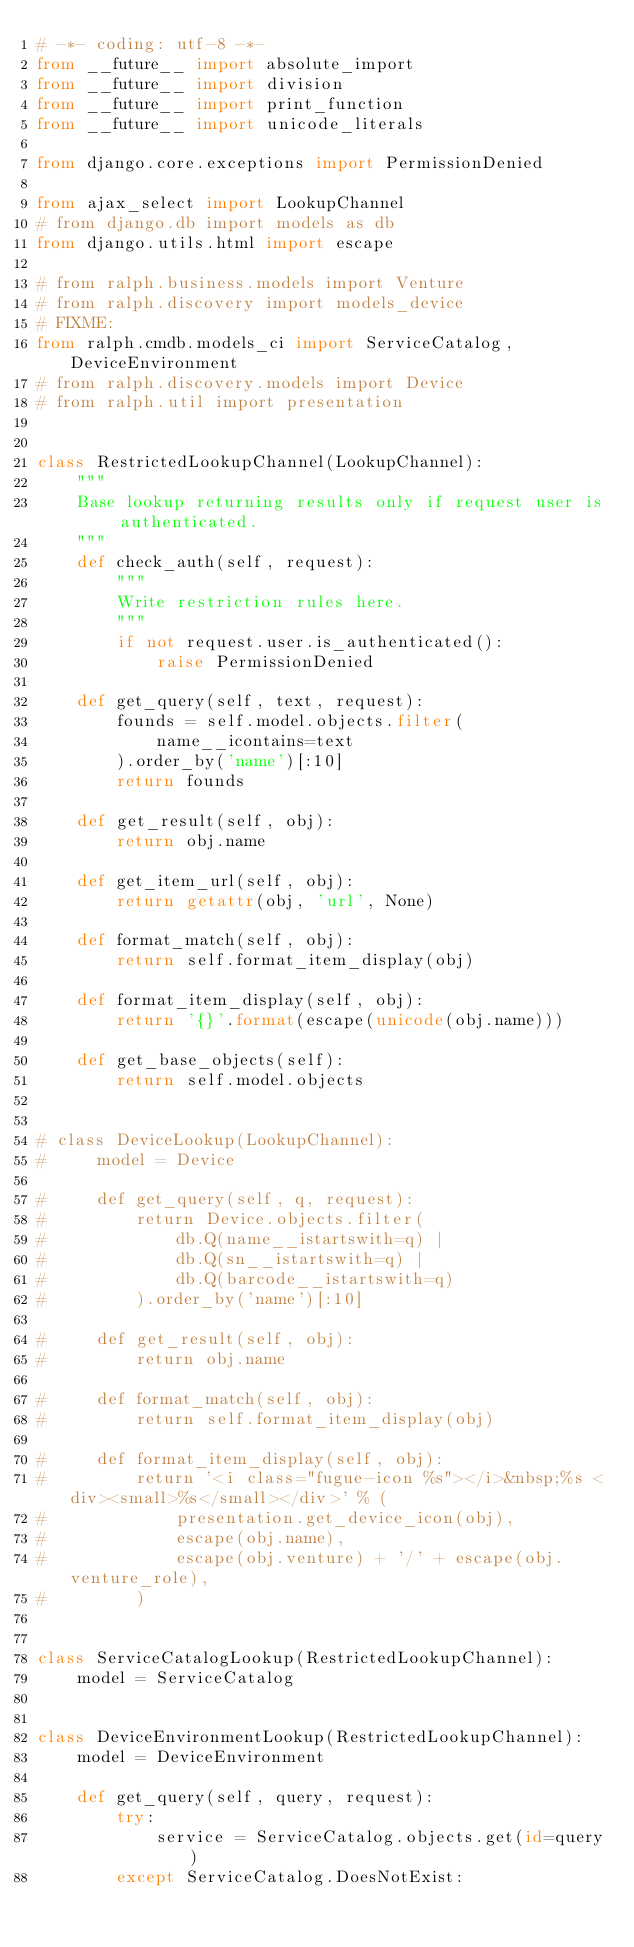Convert code to text. <code><loc_0><loc_0><loc_500><loc_500><_Python_># -*- coding: utf-8 -*-
from __future__ import absolute_import
from __future__ import division
from __future__ import print_function
from __future__ import unicode_literals

from django.core.exceptions import PermissionDenied

from ajax_select import LookupChannel
# from django.db import models as db
from django.utils.html import escape

# from ralph.business.models import Venture
# from ralph.discovery import models_device
# FIXME:
from ralph.cmdb.models_ci import ServiceCatalog, DeviceEnvironment
# from ralph.discovery.models import Device
# from ralph.util import presentation


class RestrictedLookupChannel(LookupChannel):
    """
    Base lookup returning results only if request user is authenticated.
    """
    def check_auth(self, request):
        """
        Write restriction rules here.
        """
        if not request.user.is_authenticated():
            raise PermissionDenied

    def get_query(self, text, request):
        founds = self.model.objects.filter(
            name__icontains=text
        ).order_by('name')[:10]
        return founds

    def get_result(self, obj):
        return obj.name

    def get_item_url(self, obj):
        return getattr(obj, 'url', None)

    def format_match(self, obj):
        return self.format_item_display(obj)

    def format_item_display(self, obj):
        return '{}'.format(escape(unicode(obj.name)))

    def get_base_objects(self):
        return self.model.objects


# class DeviceLookup(LookupChannel):
#     model = Device

#     def get_query(self, q, request):
#         return Device.objects.filter(
#             db.Q(name__istartswith=q) |
#             db.Q(sn__istartswith=q) |
#             db.Q(barcode__istartswith=q)
#         ).order_by('name')[:10]

#     def get_result(self, obj):
#         return obj.name

#     def format_match(self, obj):
#         return self.format_item_display(obj)

#     def format_item_display(self, obj):
#         return '<i class="fugue-icon %s"></i>&nbsp;%s <div><small>%s</small></div>' % (
#             presentation.get_device_icon(obj),
#             escape(obj.name),
#             escape(obj.venture) + '/' + escape(obj.venture_role),
#         )


class ServiceCatalogLookup(RestrictedLookupChannel):
    model = ServiceCatalog


class DeviceEnvironmentLookup(RestrictedLookupChannel):
    model = DeviceEnvironment

    def get_query(self, query, request):
        try:
            service = ServiceCatalog.objects.get(id=query)
        except ServiceCatalog.DoesNotExist:</code> 